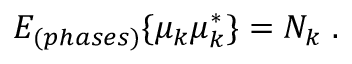<formula> <loc_0><loc_0><loc_500><loc_500>E _ { ( p h a s e s ) } \{ \mu _ { k } \mu _ { k } ^ { \ast } \} = N _ { k } \, .</formula> 